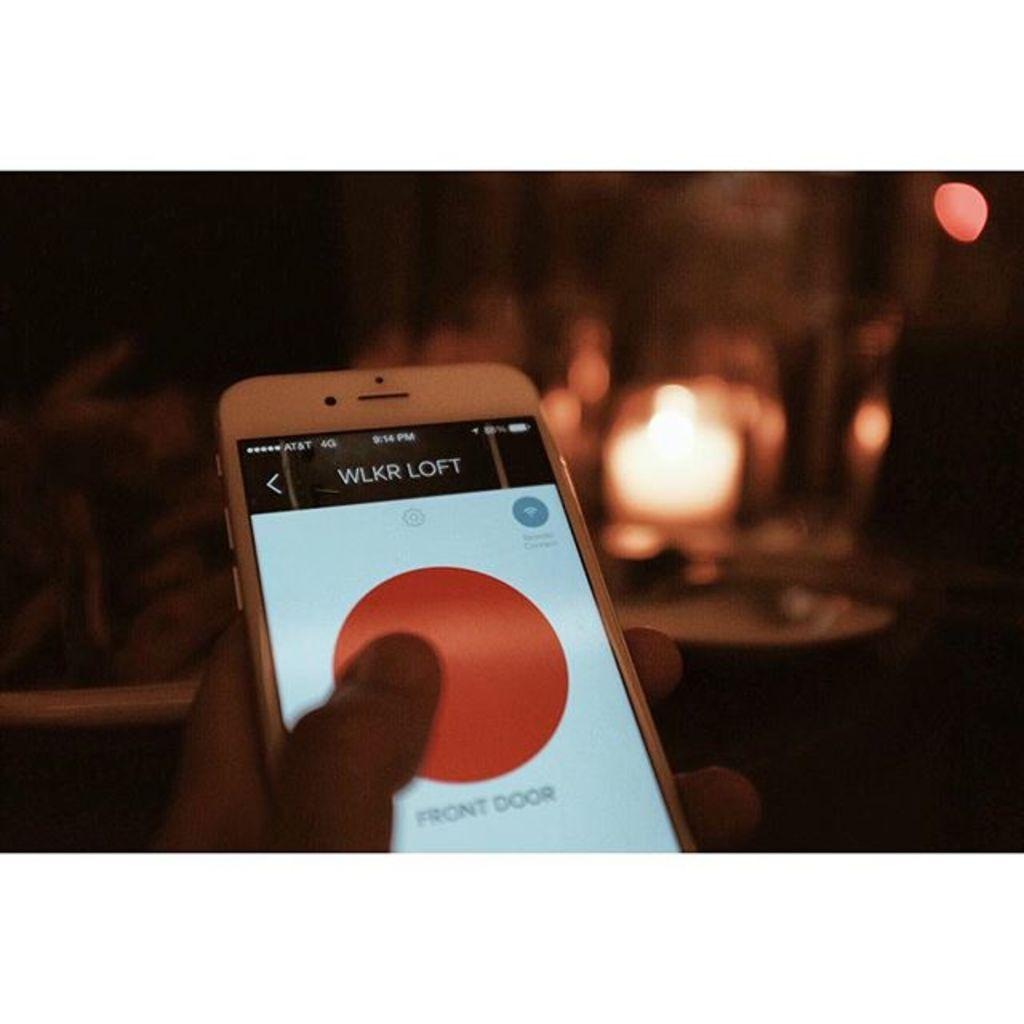Provide a one-sentence caption for the provided image. wlkr loft front door access button on a cellphone. 